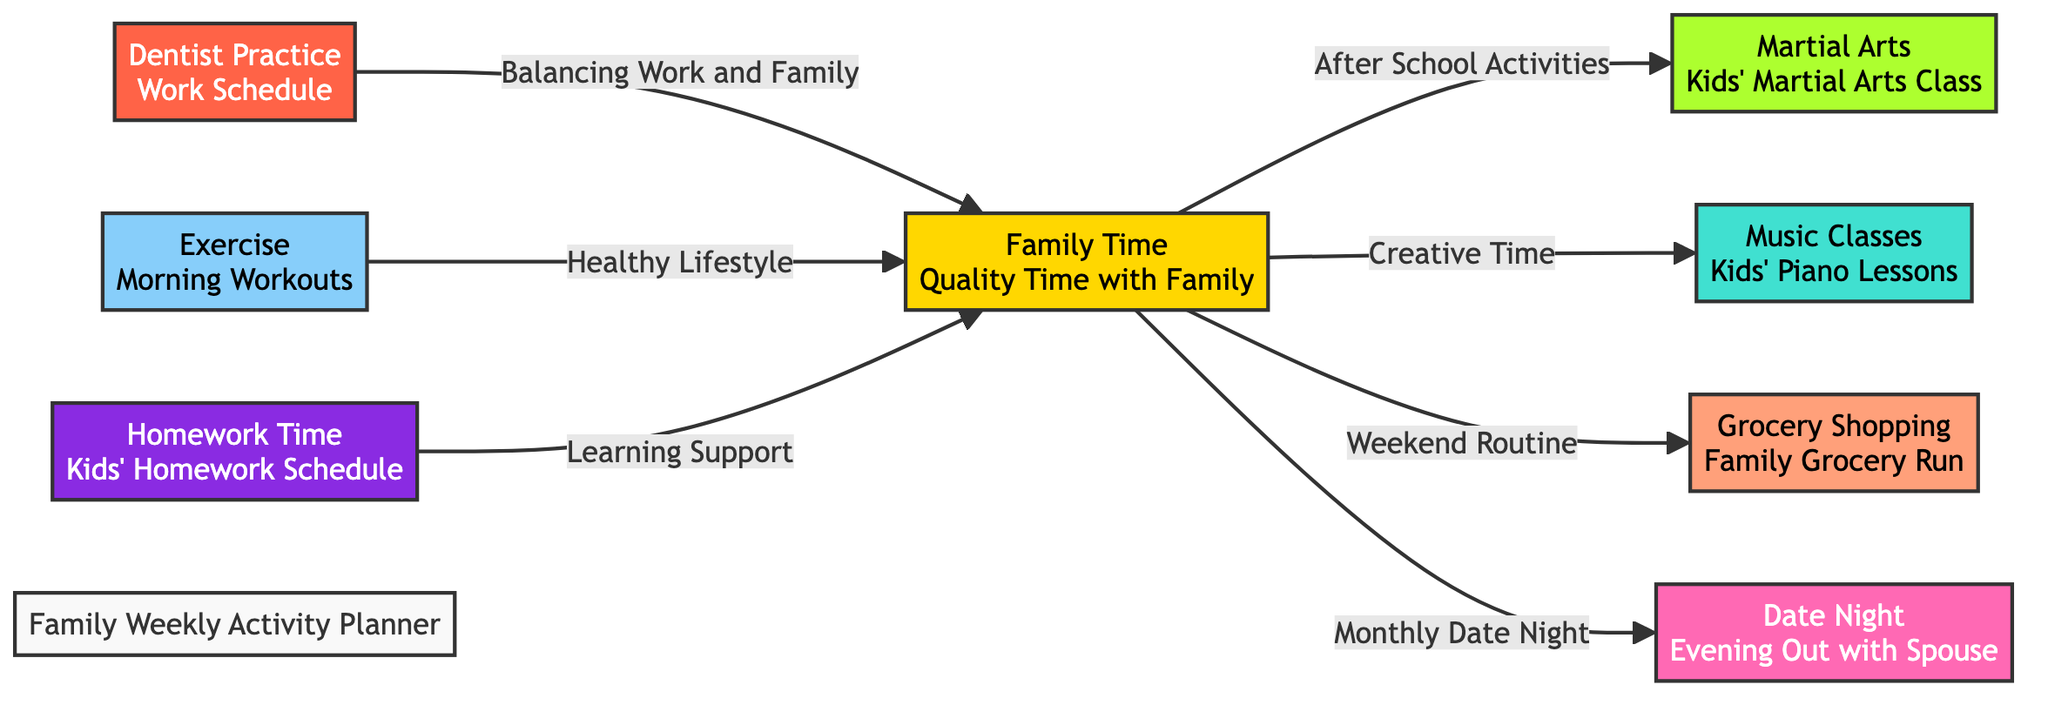What is the primary focus of the node labeled "Dentist Practice"? The node "Dentist Practice" indicates the focus is on the "Work Schedule" of the dentist's practice, emphasizing the professional commitments required.
Answer: Work Schedule How many activities directly connect to "Family Time"? The diagram shows five activities that flow from "Family Time," indicating various scheduled events or activities tied to family involvement.
Answer: Five Which activity involves a monthly occurrence? The "Date Night" node mentions a frequency, specifically noting that it is a "Monthly Date Night," indicating its regular occurrence.
Answer: Monthly Date Night What is the connection between "Exercise" and "Family Time"? The flow from "Exercise" to "Family Time" indicates that engaging in exercise contributes to a "Healthy Lifestyle," which benefits the quality of family time.
Answer: Healthy Lifestyle What are the two activities linked to children's engagement? The diagram indicates two activities—"Martial Arts" and "Music Classes"—specifically catered to children's extracurricular engagements during family time.
Answer: Martial Arts, Music Classes How does "Homework Time" influence "Family Time"? "Homework Time" connects to "Family Time" with the label "Learning Support," suggesting that the scheduled homework helps in maintaining supportive family interactions and routines.
Answer: Learning Support What does "Grocery Shopping" represent in the context of the family planner? The "Grocery Shopping" node signifies a "Weekend Routine," indicating this activity is a regular part of the family's weekly planning for collective engagement.
Answer: Weekend Routine Which node represents time dedicated solely to the spouse? The "Date Night" node specifically denotes an evening out focused solely on spending time with the spouse, as indicated by its title.
Answer: Date Night What is the color code for "Music Classes" in the diagram? The node "Music Classes" is colored with a shade representing "music," specifically noted by the color code green, which is common for musical activities.
Answer: Music color code How do family activities categorize based on color? The diagram groups activities into color categories, such as "family," "practice," "martial," "music," "grocery," "date," "exercise," and "homework," illustrating their distinct roles within the planner.
Answer: Color categories 